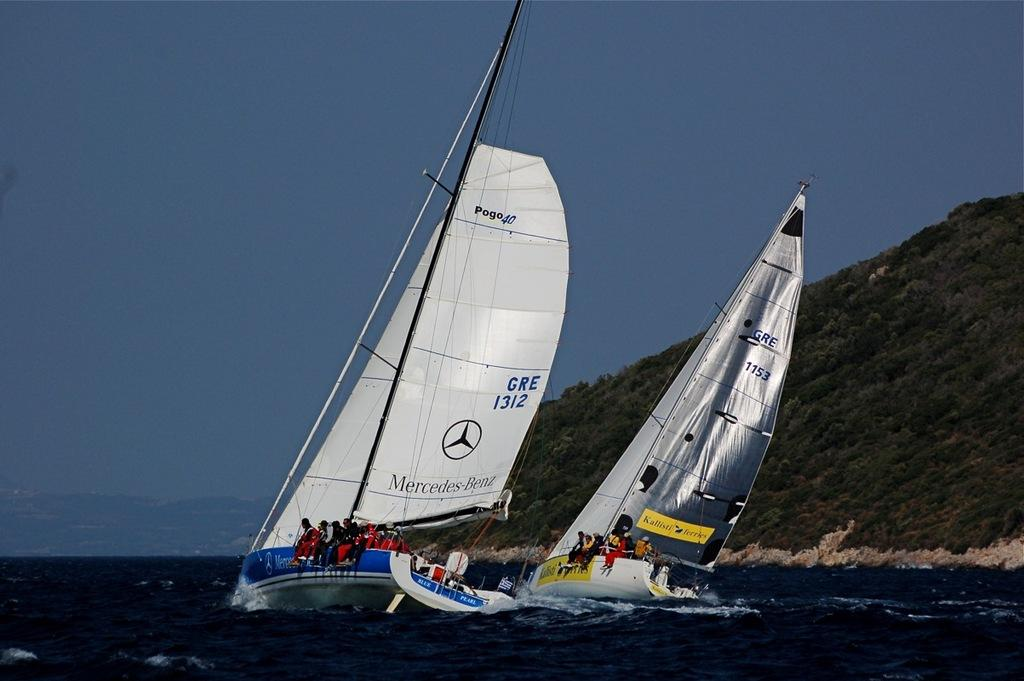What is happening in the foreground of the image? There is a group of people in the foreground of the image. What are the people doing in the image? The people are in boats. What can be seen in the background of the image? There are trees, mountains, and the sky visible in the background of the image. What type of environment is depicted in the image? The image may have been taken in the ocean, as there is water visible. What type of spy equipment can be seen in the image? There is no spy equipment present in the image; it features a group of people in boats on water, with trees, mountains, and the sky visible in the background. How does the acoustics of the trees affect the sound in the image? There is no mention of sound or acoustics in the image, as it primarily focuses on the visual elements of the scene. 